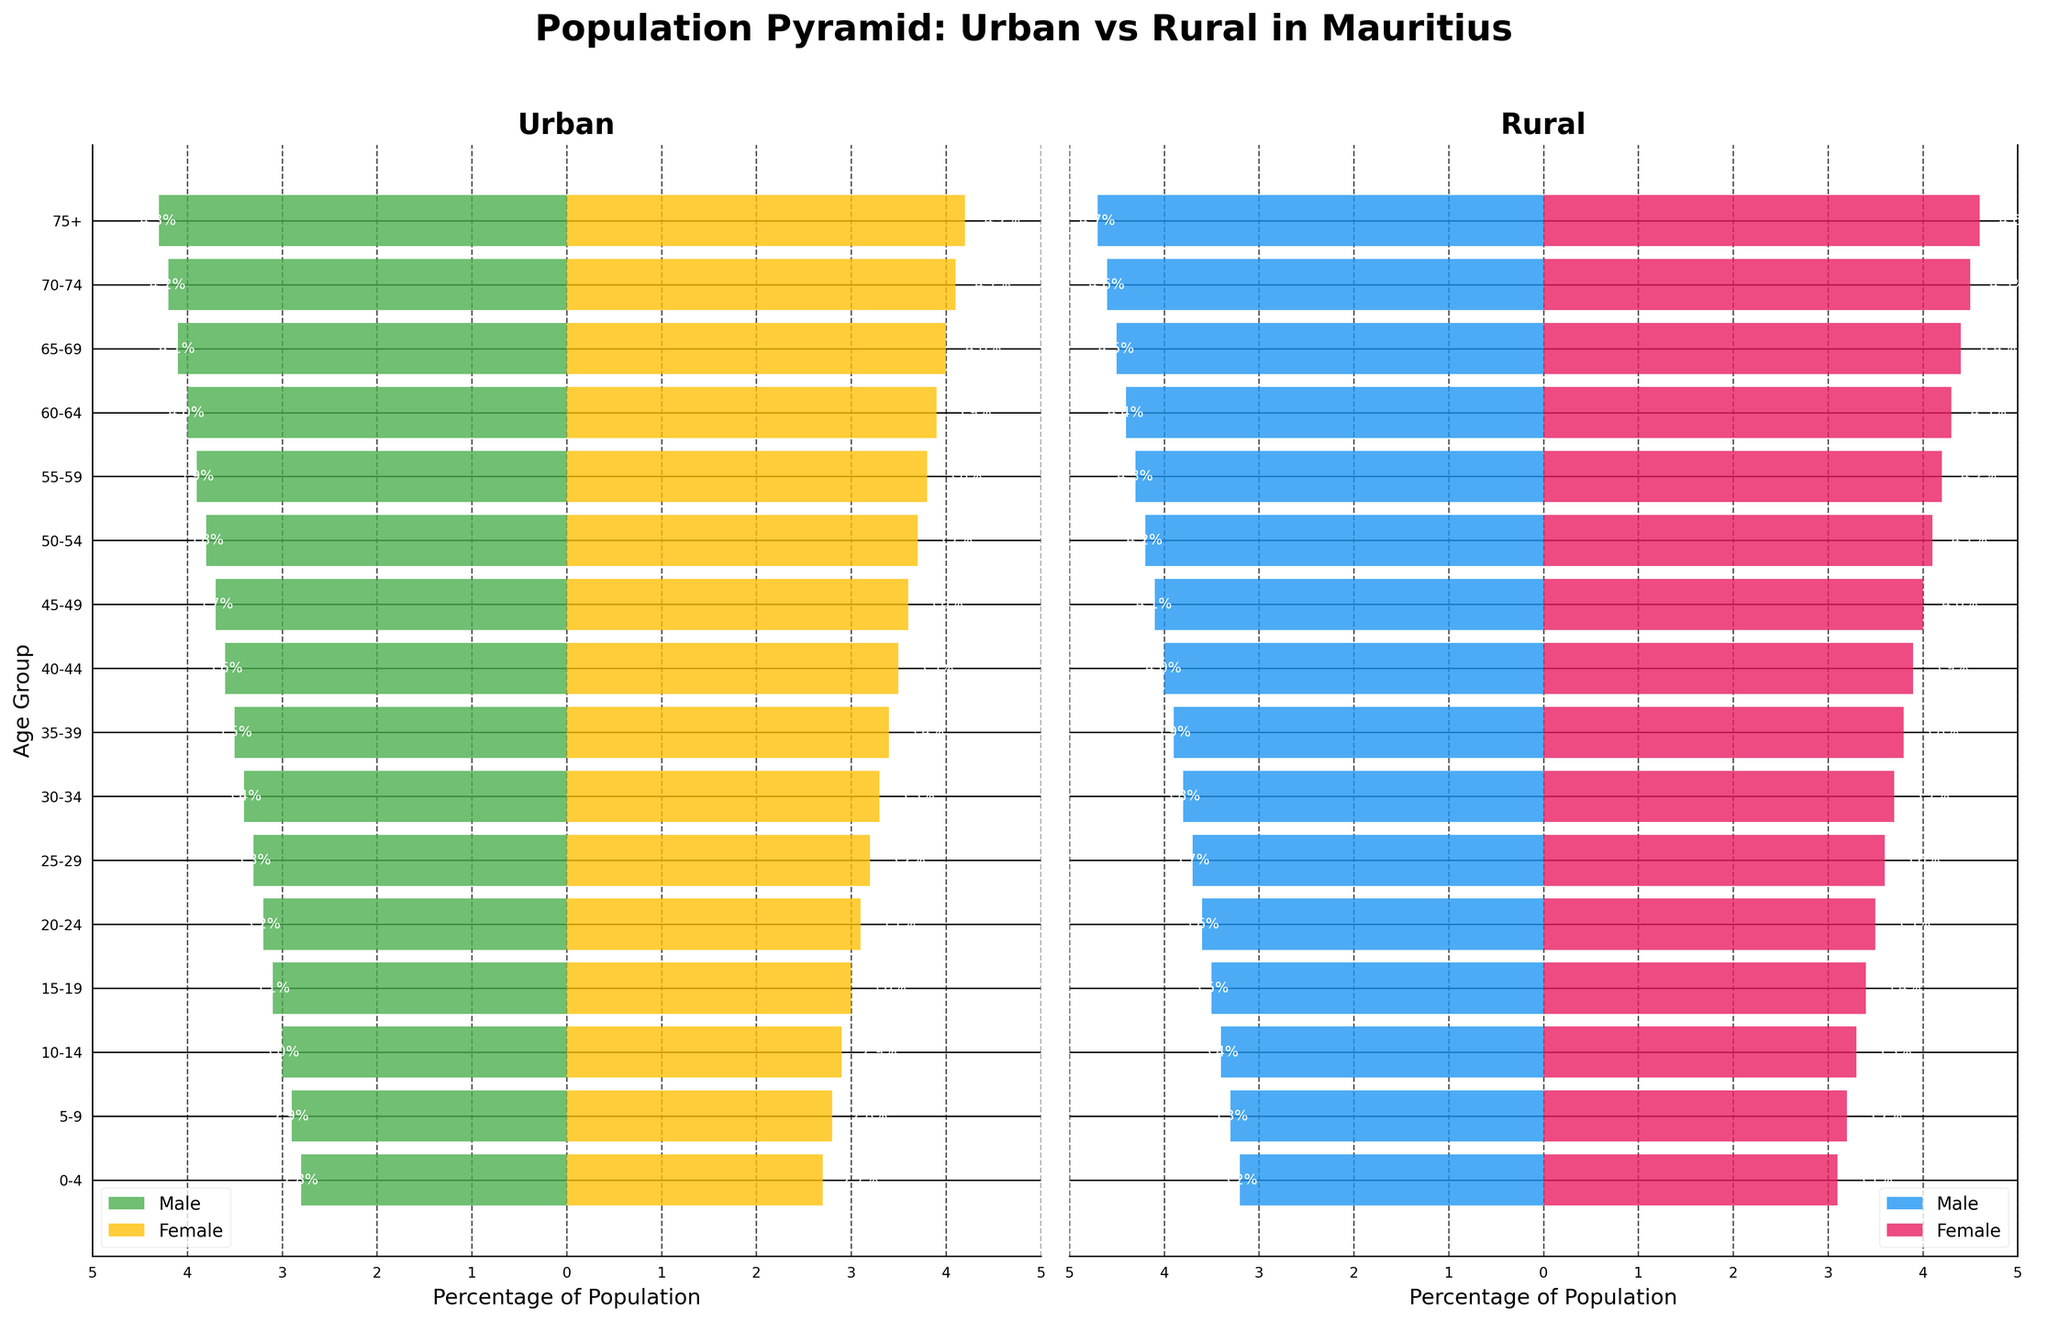How is the population pyramid titled? The title of the population pyramid is found at the top of the figure. It is "Population Pyramid: Urban vs Rural in Mauritius", indicating that the pyramid compares urban and rural population age structures in Mauritius.
Answer: Population Pyramid: Urban vs Rural in Mauritius What colors represent males and females in urban areas? The bars for urban areas are colored differently for males and females. Urban males are represented by green bars, and urban females are represented by yellow bars.
Answer: Green for males, yellow for females What age group has the highest percentage population in rural females? To find the age group with the highest percentage for rural females, look for the longest pink bar on the rural side (right side of the pyramid). The age group 75+ has the longest pink bar representing 4.6%.
Answer: 75+ Which group has a larger percentage of males in the 15-19 age group, urban or rural? Compare the lengths of the bars for males aged 15-19 in the urban and rural sections. The rural bar is longer at 3.5% compared to the urban bar at 3.1%. Therefore, rural males aged 15-19 have a larger percentage.
Answer: Rural What is the percentage difference between urban and rural females in the 25-29 age group? Identify the percentages of urban and rural females in the 25-29 age group. Urban females are 3.2% and rural females are 3.6%. The difference is calculated as 3.6% - 3.2% = 0.4%.
Answer: 0.4% What is the average percentage of population for urban females across all age groups? To find the average percentage of urban females, sum all the percentages for urban females and divide by the number of age groups. The calculation is (2.7 + 2.8 + 2.9 + 3.0 + 3.1 + 3.2 + 3.3 + 3.4 + 3.5 + 3.6 + 3.7 + 3.8 + 3.9 + 4.0 + 4.1 + 4.2) / 16 = 3.375%.
Answer: 3.375% In which age group do urban and rural populations have the smallest percentage difference for males? Check the percentages for urban and rural males in each age group and find the smallest difference. For the 0-4 age group, the percentages are 2.8% for urban and 3.2% for rural, with a difference of 0.4%, which is the smallest.
Answer: 0-4 Do the older age groups (55+ years) show a higher population percentage in urban or rural areas? Compare the bars representing populations aged 55 and older (55-59, 60-64, 65-69, 70-74, 75+) in both urban and rural areas. The rural areas consistently show higher percentages in these age groups.
Answer: Rural Which has a higher percentage of females in the 40-44 age group, urban or rural? Compare the female percentages in the 40-44 age group for urban and rural areas. For urban females, it is 3.5%, while for rural females, it is 3.9%, making rural females higher.
Answer: Rural 